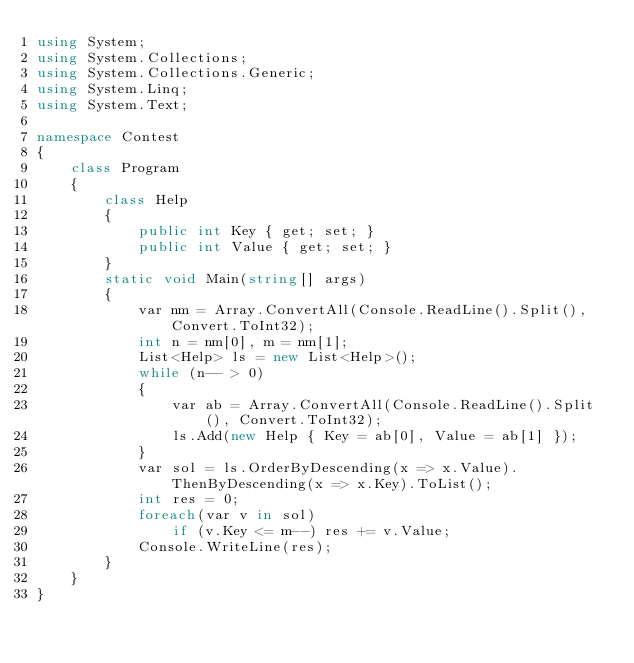Convert code to text. <code><loc_0><loc_0><loc_500><loc_500><_C#_>using System;
using System.Collections;
using System.Collections.Generic;
using System.Linq;
using System.Text;

namespace Contest
{
    class Program
    {
        class Help
        {
            public int Key { get; set; }
            public int Value { get; set; }
        }
        static void Main(string[] args)
        {
            var nm = Array.ConvertAll(Console.ReadLine().Split(), Convert.ToInt32);
            int n = nm[0], m = nm[1];
            List<Help> ls = new List<Help>();
            while (n-- > 0)
            {
                var ab = Array.ConvertAll(Console.ReadLine().Split(), Convert.ToInt32);
                ls.Add(new Help { Key = ab[0], Value = ab[1] });
            }
            var sol = ls.OrderByDescending(x => x.Value).ThenByDescending(x => x.Key).ToList();
            int res = 0;
            foreach(var v in sol)
                if (v.Key <= m--) res += v.Value;
            Console.WriteLine(res);
        }
    }
}</code> 